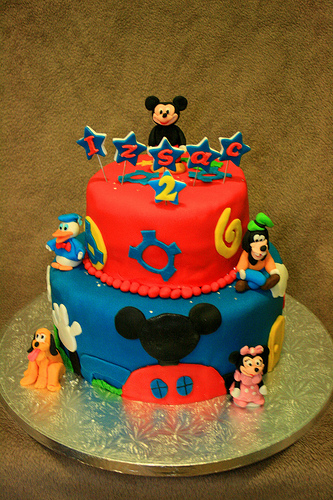<image>
Is there a dog to the left of the plate? No. The dog is not to the left of the plate. From this viewpoint, they have a different horizontal relationship. Is there a pluto in front of the minnie? No. The pluto is not in front of the minnie. The spatial positioning shows a different relationship between these objects. 